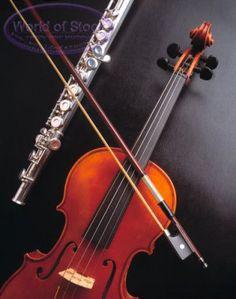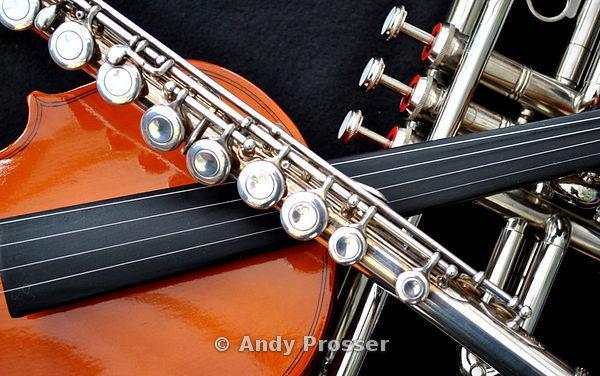The first image is the image on the left, the second image is the image on the right. Considering the images on both sides, is "A violin bow is touching violin strings and a flute." valid? Answer yes or no. Yes. The first image is the image on the left, the second image is the image on the right. Examine the images to the left and right. Is the description "An image features items displayed overlapping on a flat surface, including a violin, sheet music, and a straight wind instrument in pieces." accurate? Answer yes or no. No. 